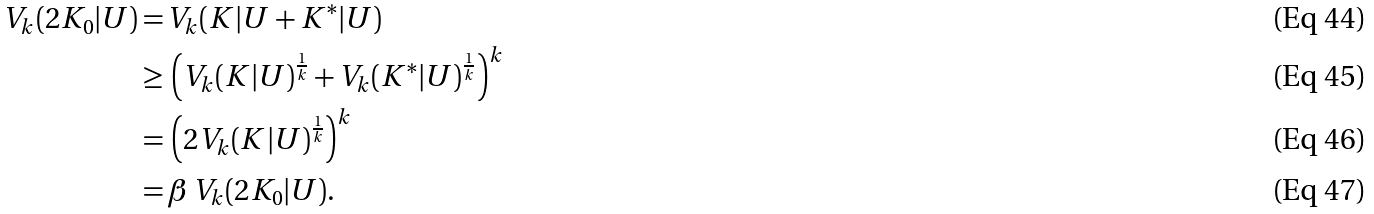Convert formula to latex. <formula><loc_0><loc_0><loc_500><loc_500>V _ { k } ( 2 K _ { 0 } | U ) = \, & V _ { k } ( K | U + K ^ { * } | U ) \\ \geq \, & \left ( V _ { k } ( K | U ) ^ { \frac { 1 } { k } } + V _ { k } ( K ^ { * } | U ) ^ { \frac { 1 } { k } } \right ) ^ { k } \\ = \, & \left ( 2 V _ { k } ( K | U ) ^ { \frac { 1 } { k } } \right ) ^ { k } \\ = \, & \beta \, V _ { k } ( 2 K _ { 0 } | U ) .</formula> 